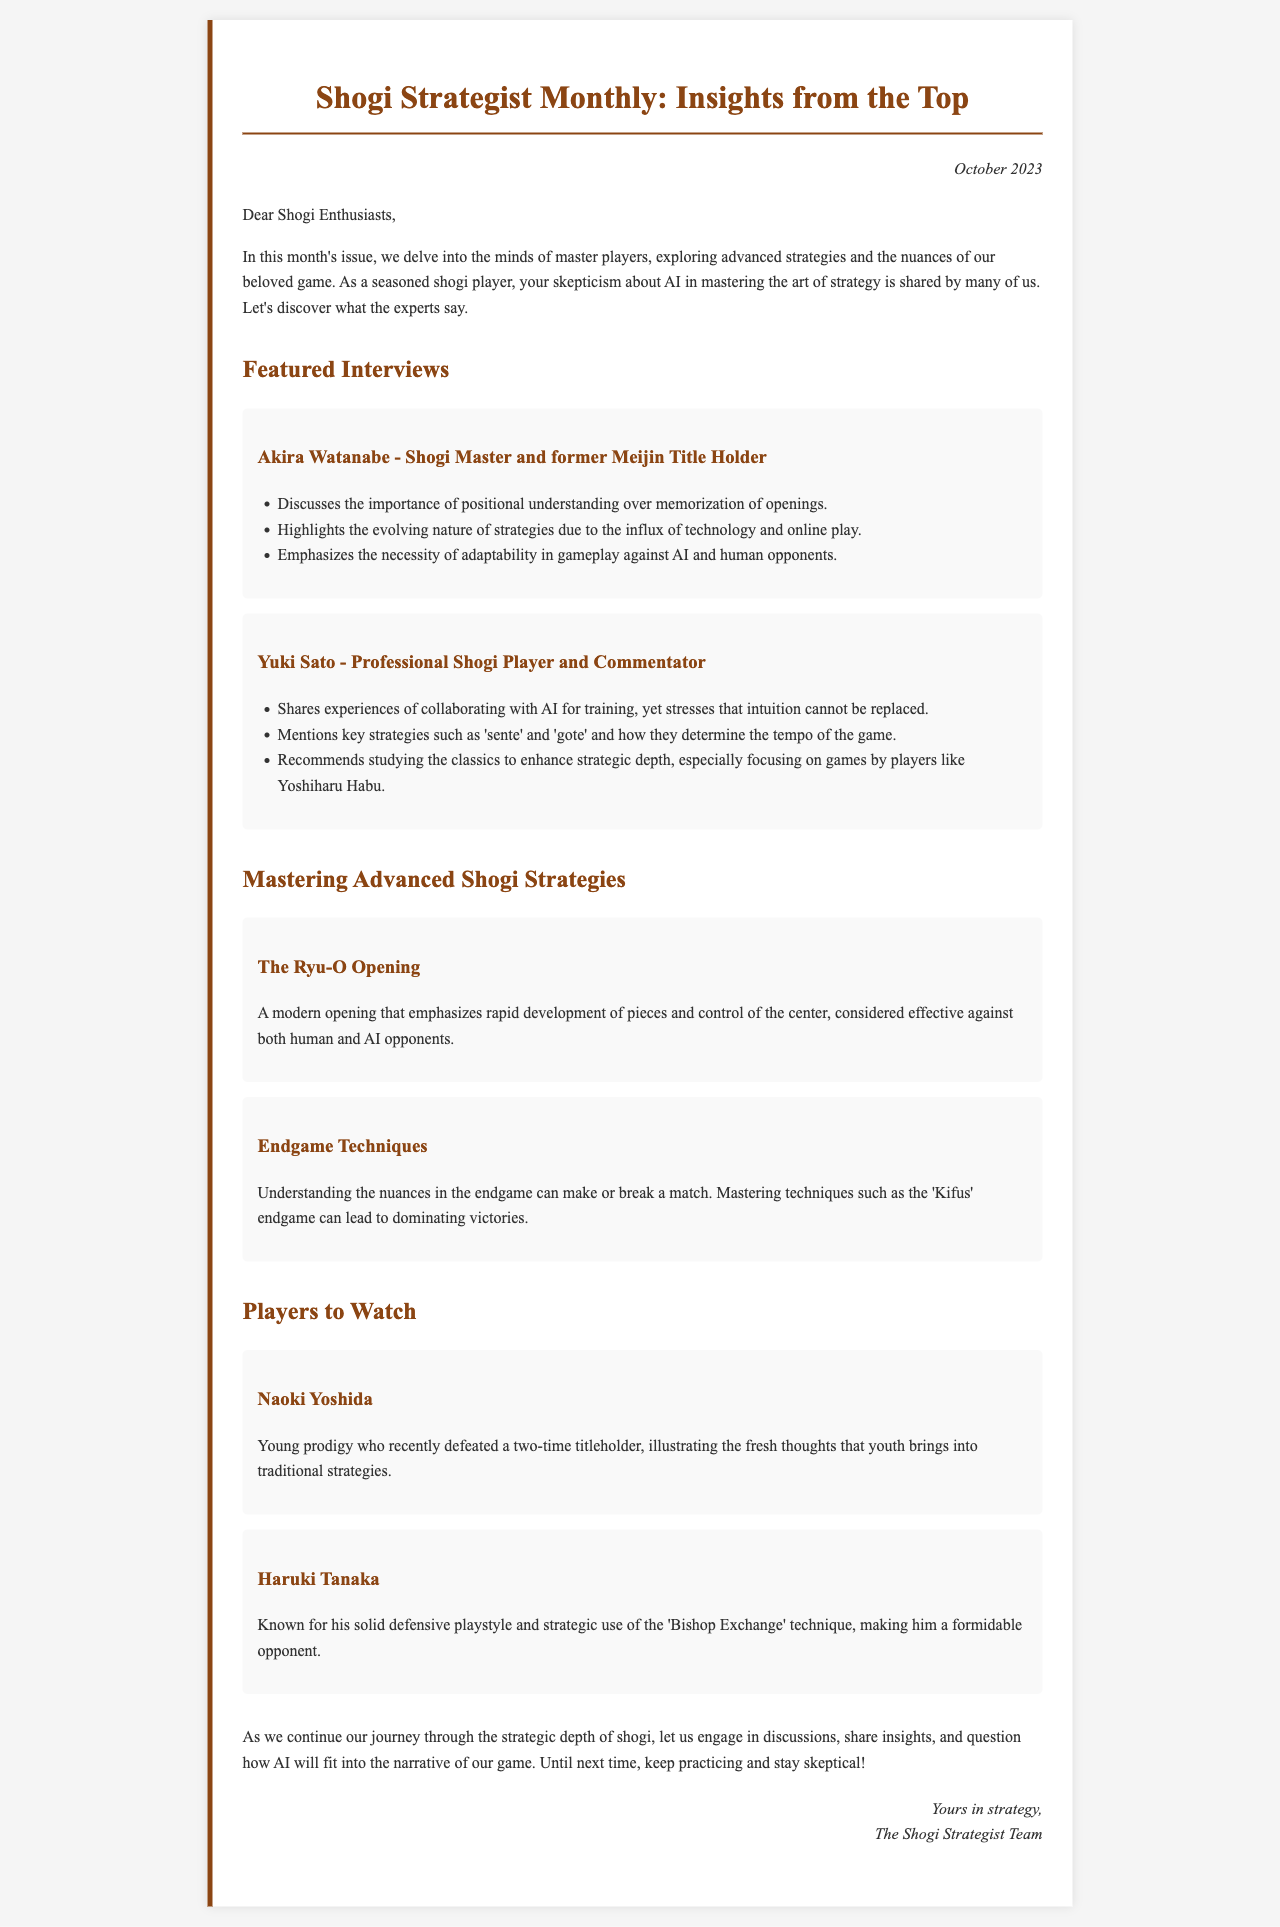What is the title of the newsletter? The title of the newsletter is presented prominently at the top of the document.
Answer: Shogi Strategist Monthly: Insights from the Top Who is the featured player interviewed in this issue that is a former Meijin title holder? This is specifically stated in the interview section of the document.
Answer: Akira Watanabe What is the date mentioned in the document? The date of the newsletter is given in the issue date section.
Answer: October 2023 What strategy does Yuki Sato mention regarding the tempo of the game? This is one of the key strategies discussed in Yuki Sato's interview.
Answer: sente and gote Which technique is known for solid defensive playstyle in players to watch? The document specifically describes this technique in the highlight section.
Answer: Bishop Exchange How does Akira Watanabe believe game strategies have evolved? This reflects his insights during the interview about changes in strategies.
Answer: Evolving nature due to technology and online play What is the Ryu-O Opening focused on? This is mentioned in the section discussing advanced shogi strategies.
Answer: Rapid development of pieces and control of the center What does the signature at the end of the letter indicate? The signature conveys the authorship of the document.
Answer: The Shogi Strategist Team 